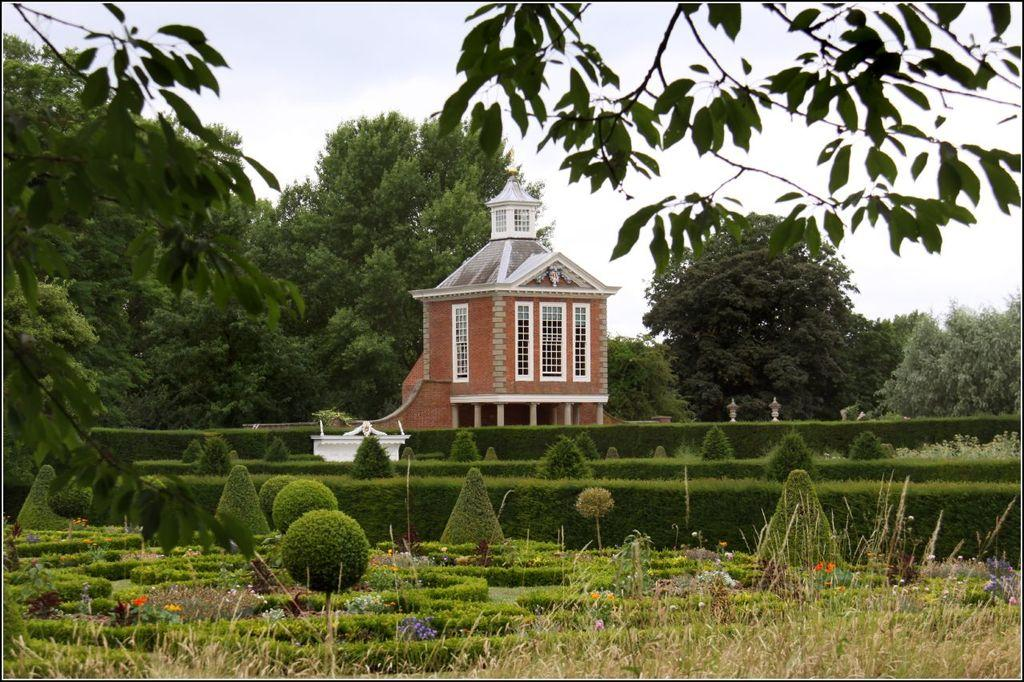What type of structure is visible in the image? There is a building in the image. What other natural elements can be seen in the image? There are trees and plants visible in the image. What is visible at the top of the image? The sky is visible at the top of the image. What specific detail can be observed about the plants in the foreground? The plants in the foreground have flowers on them. How do we know that the image has been edited? The fact that the image has been edited is mentioned in the provided information. Can you see a beggar asking for money in the image? There is no beggar present in the image. Is there a gun visible in the image? There is no gun present in the image. What type of pollution can be seen in the image? There is no pollution visible in the image. 